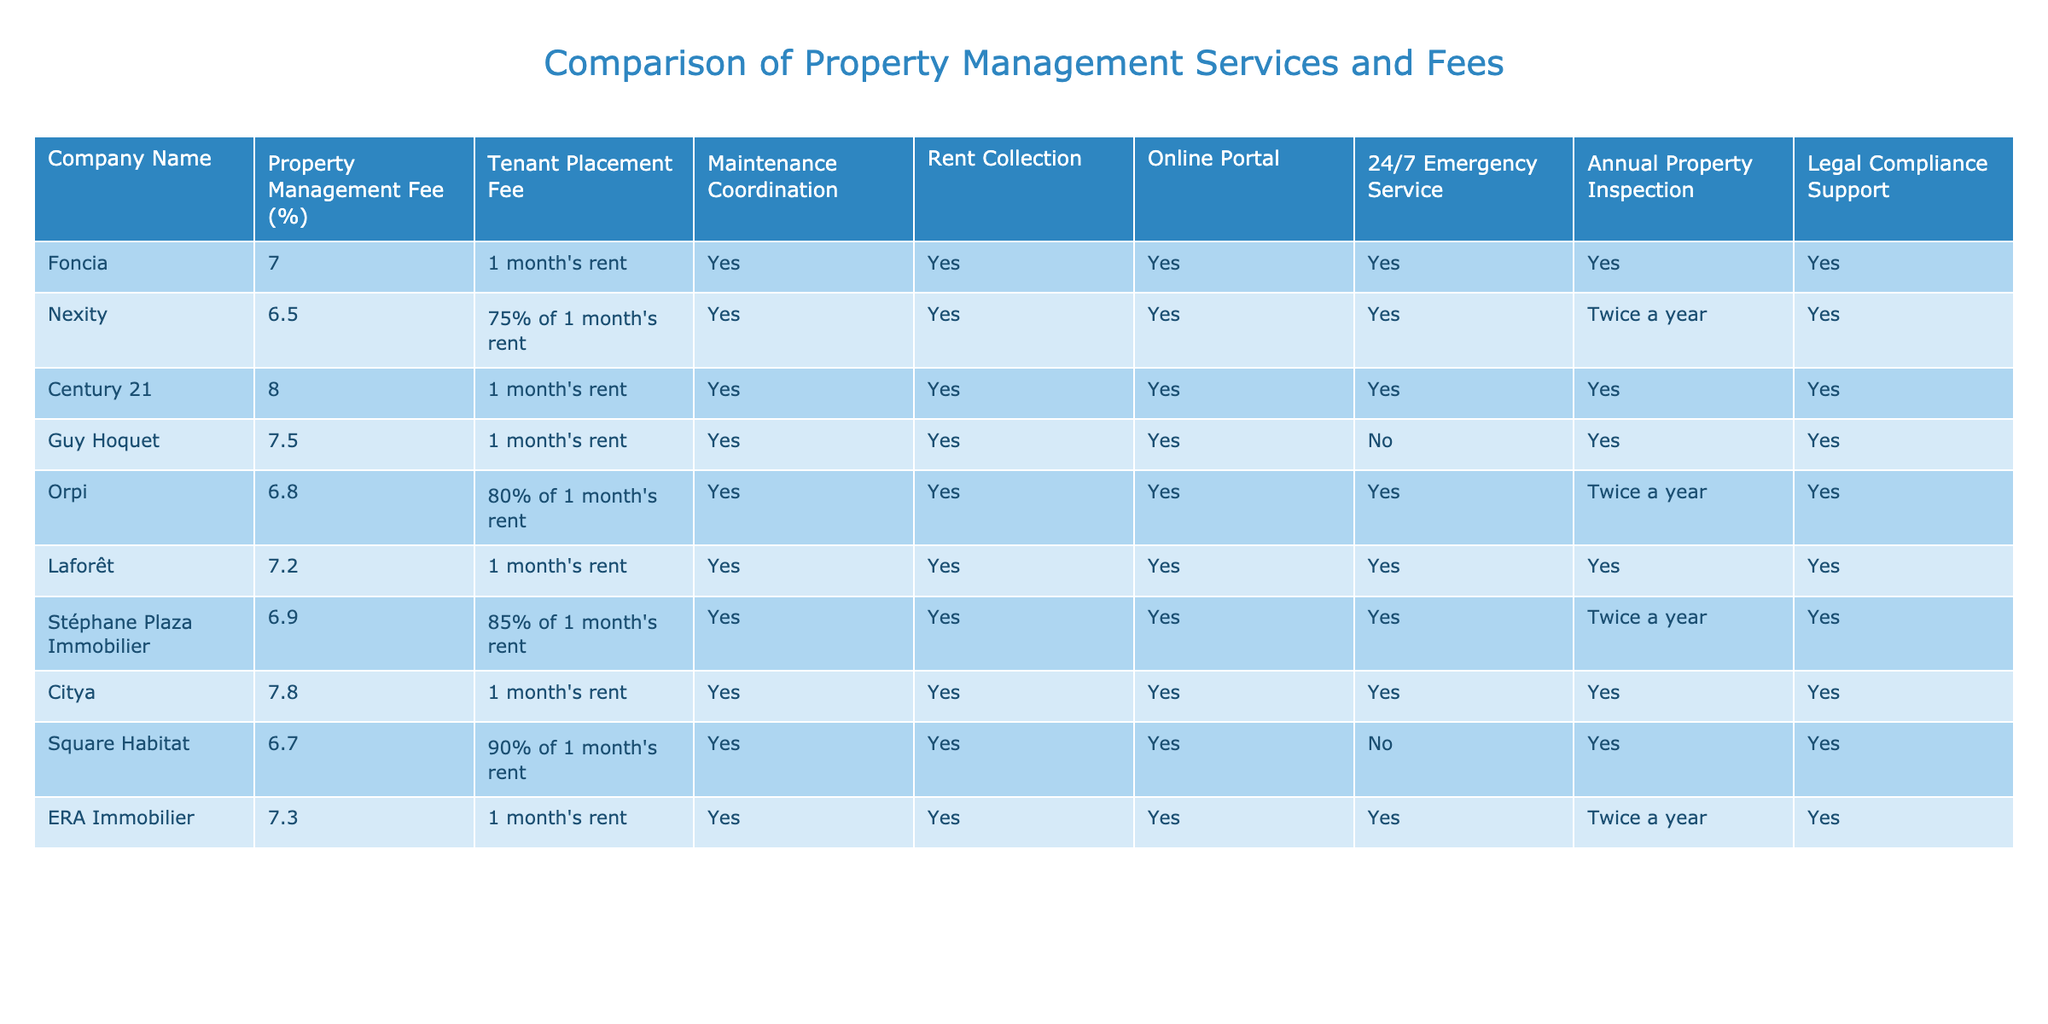What is the lowest property management fee among the companies listed? By examining the column for Property Management Fee (%), the lowest fee is 6.5% from Nexity.
Answer: 6.5% Which companies offer 24/7 emergency service? The companies that provide 24/7 emergency service are Foncia, Nexity, Century 21, Orpi, Laforêt, Citya, and ERA Immobilier as indicated by 'Yes' in the respective column.
Answer: 7 companies What is the tenant placement fee for Guy Hoquet? The table shows that the tenant placement fee for Guy Hoquet is 1 month's rent.
Answer: 1 month's rent Which company has the highest annual property inspection frequency? Upon reviewing the annual property inspection frequencies, Foncia, Century 21, Guy Hoquet, Laforêt, Citya, and ERA Immobilier all have an inspection frequency, but only Nexity, Orpi, and Stéphane Plaza Immobilier conduct them twice a year. Thus, the highest standard seen among the companies is "Twice a year."
Answer: Twice a year What percentage difference exists between the lowest and highest property management fees? The lowest fee is 6.5% (Nexity) and the highest fee is 8% (Century 21). The difference is 8 - 6.5 = 1.5%.
Answer: 1.5% Does Square Habitat provide legal compliance support? According to the table, Square Habitat has 'Yes' listed under the legal compliance support column, indicating that it does provide this service.
Answer: Yes How many companies perform maintenance coordination? By checking each entry in the Maintenance Coordination column, all companies except for Square Habitat perform maintenance coordination. Since there are 10 companies, 9 offer this service.
Answer: 9 companies Which company has the same tenant placement fee as Laforêt? By analyzing the tenant placement fee column, Laforêt's fee of 1 month's rent matches with Foncia and Century 21, who also have the same fee schedule.
Answer: Foncia and Century 21 What is the average property management fee for the listed companies? Adding all the management fees (7, 6.5, 8, 7.5, 6.8, 7.2, 6.9, 7.8, 6.7, 7.3) gives a total of 69.7%. Dividing this by the total number of companies (10) gives an average of 6.97%.
Answer: 6.97% Which company has the tenant placement fee listed as 75% of 1 month's rent? Checking the tenant placement fee column reveals that Nexity charges 75% of 1 month's rent as the fee.
Answer: Nexity 